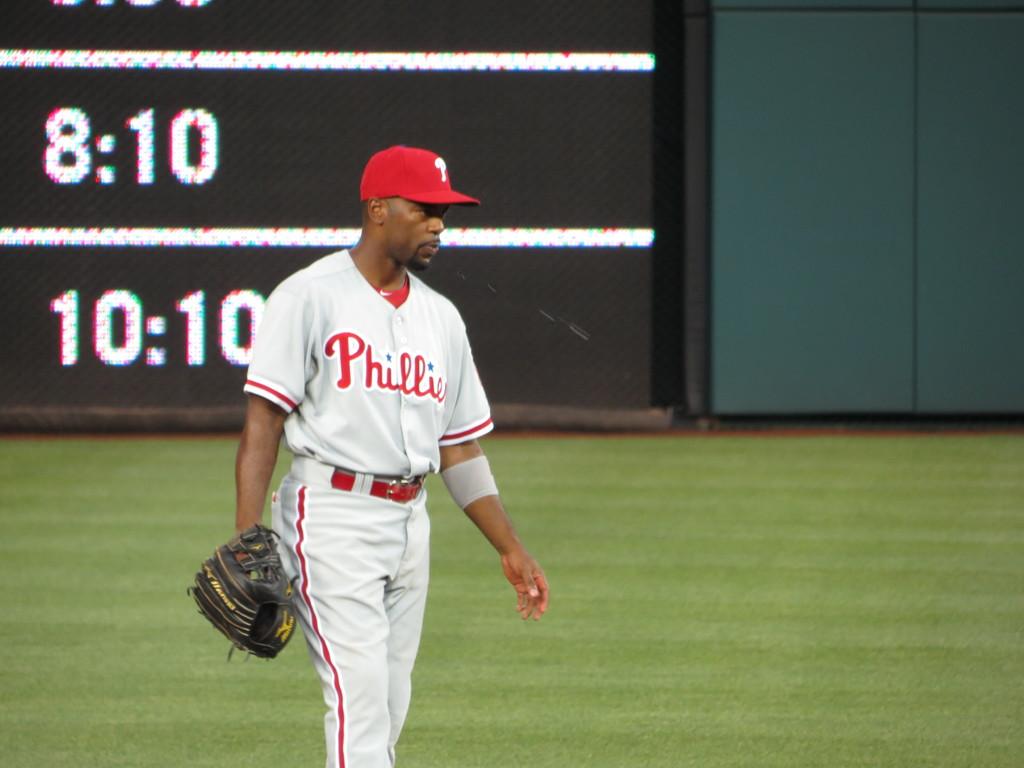What team does this outfielder represent?
Provide a succinct answer. Phillies. What is one of the numbers on the screen behind him?
Provide a short and direct response. 8:10. 